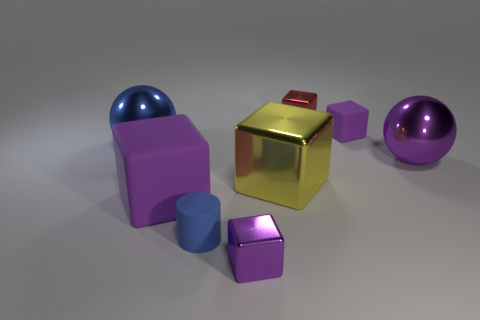How big is the metal ball on the right side of the large blue ball?
Give a very brief answer. Large. There is a yellow block that is made of the same material as the red thing; what size is it?
Offer a terse response. Large. What number of metal balls have the same color as the small cylinder?
Provide a succinct answer. 1. Are any purple metallic balls visible?
Provide a succinct answer. Yes. There is a blue metallic thing; does it have the same shape as the large purple thing that is in front of the purple sphere?
Your answer should be compact. No. What is the color of the large metal sphere that is on the right side of the purple thing behind the big purple shiny object that is behind the tiny blue rubber cylinder?
Provide a succinct answer. Purple. There is a yellow metallic cube; are there any small blue rubber cylinders left of it?
Provide a short and direct response. Yes. What size is the metal block that is the same color as the tiny matte block?
Offer a terse response. Small. Are there any large things that have the same material as the small blue object?
Provide a succinct answer. Yes. The big shiny cube has what color?
Your answer should be compact. Yellow. 